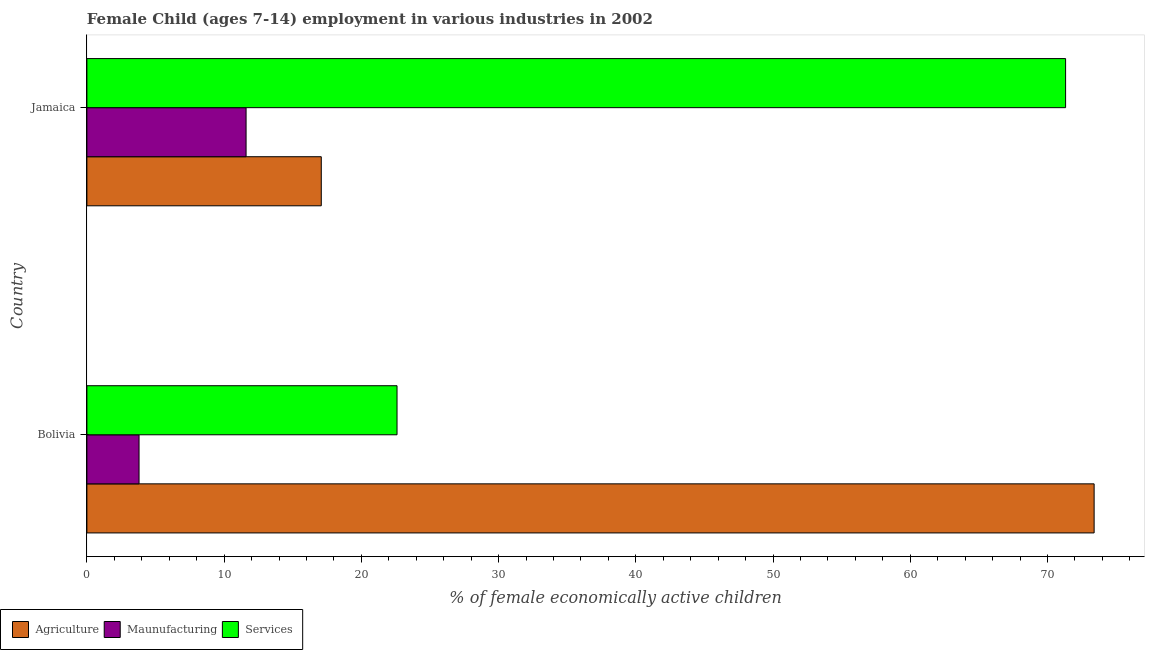How many different coloured bars are there?
Offer a terse response. 3. Across all countries, what is the maximum percentage of economically active children in agriculture?
Provide a short and direct response. 73.4. Across all countries, what is the minimum percentage of economically active children in agriculture?
Your response must be concise. 17.08. In which country was the percentage of economically active children in services maximum?
Your answer should be very brief. Jamaica. What is the total percentage of economically active children in manufacturing in the graph?
Give a very brief answer. 15.4. What is the difference between the percentage of economically active children in agriculture in Bolivia and that in Jamaica?
Provide a succinct answer. 56.32. What is the difference between the percentage of economically active children in manufacturing in Bolivia and the percentage of economically active children in services in Jamaica?
Your answer should be compact. -67.52. What is the average percentage of economically active children in agriculture per country?
Keep it short and to the point. 45.24. What is the difference between the percentage of economically active children in agriculture and percentage of economically active children in manufacturing in Bolivia?
Give a very brief answer. 69.6. In how many countries, is the percentage of economically active children in services greater than 74 %?
Provide a short and direct response. 0. What is the ratio of the percentage of economically active children in manufacturing in Bolivia to that in Jamaica?
Give a very brief answer. 0.33. Is the percentage of economically active children in manufacturing in Bolivia less than that in Jamaica?
Provide a succinct answer. Yes. What does the 1st bar from the top in Jamaica represents?
Make the answer very short. Services. What does the 3rd bar from the bottom in Bolivia represents?
Provide a short and direct response. Services. Are all the bars in the graph horizontal?
Your response must be concise. Yes. What is the difference between two consecutive major ticks on the X-axis?
Your answer should be very brief. 10. Are the values on the major ticks of X-axis written in scientific E-notation?
Provide a short and direct response. No. How many legend labels are there?
Keep it short and to the point. 3. What is the title of the graph?
Give a very brief answer. Female Child (ages 7-14) employment in various industries in 2002. What is the label or title of the X-axis?
Offer a terse response. % of female economically active children. What is the label or title of the Y-axis?
Your answer should be very brief. Country. What is the % of female economically active children in Agriculture in Bolivia?
Keep it short and to the point. 73.4. What is the % of female economically active children in Maunufacturing in Bolivia?
Offer a very short reply. 3.8. What is the % of female economically active children in Services in Bolivia?
Your response must be concise. 22.6. What is the % of female economically active children in Agriculture in Jamaica?
Your answer should be compact. 17.08. What is the % of female economically active children in Services in Jamaica?
Offer a terse response. 71.32. Across all countries, what is the maximum % of female economically active children in Agriculture?
Your answer should be compact. 73.4. Across all countries, what is the maximum % of female economically active children of Maunufacturing?
Offer a very short reply. 11.6. Across all countries, what is the maximum % of female economically active children in Services?
Offer a terse response. 71.32. Across all countries, what is the minimum % of female economically active children in Agriculture?
Offer a terse response. 17.08. Across all countries, what is the minimum % of female economically active children in Services?
Make the answer very short. 22.6. What is the total % of female economically active children in Agriculture in the graph?
Offer a very short reply. 90.48. What is the total % of female economically active children in Maunufacturing in the graph?
Keep it short and to the point. 15.4. What is the total % of female economically active children in Services in the graph?
Keep it short and to the point. 93.92. What is the difference between the % of female economically active children of Agriculture in Bolivia and that in Jamaica?
Provide a succinct answer. 56.32. What is the difference between the % of female economically active children in Services in Bolivia and that in Jamaica?
Your answer should be very brief. -48.72. What is the difference between the % of female economically active children of Agriculture in Bolivia and the % of female economically active children of Maunufacturing in Jamaica?
Provide a short and direct response. 61.8. What is the difference between the % of female economically active children in Agriculture in Bolivia and the % of female economically active children in Services in Jamaica?
Offer a very short reply. 2.08. What is the difference between the % of female economically active children in Maunufacturing in Bolivia and the % of female economically active children in Services in Jamaica?
Make the answer very short. -67.52. What is the average % of female economically active children of Agriculture per country?
Your answer should be compact. 45.24. What is the average % of female economically active children of Services per country?
Provide a short and direct response. 46.96. What is the difference between the % of female economically active children in Agriculture and % of female economically active children in Maunufacturing in Bolivia?
Ensure brevity in your answer.  69.6. What is the difference between the % of female economically active children in Agriculture and % of female economically active children in Services in Bolivia?
Your response must be concise. 50.8. What is the difference between the % of female economically active children of Maunufacturing and % of female economically active children of Services in Bolivia?
Your answer should be very brief. -18.8. What is the difference between the % of female economically active children in Agriculture and % of female economically active children in Maunufacturing in Jamaica?
Ensure brevity in your answer.  5.48. What is the difference between the % of female economically active children in Agriculture and % of female economically active children in Services in Jamaica?
Your response must be concise. -54.24. What is the difference between the % of female economically active children of Maunufacturing and % of female economically active children of Services in Jamaica?
Give a very brief answer. -59.72. What is the ratio of the % of female economically active children in Agriculture in Bolivia to that in Jamaica?
Offer a very short reply. 4.3. What is the ratio of the % of female economically active children of Maunufacturing in Bolivia to that in Jamaica?
Make the answer very short. 0.33. What is the ratio of the % of female economically active children in Services in Bolivia to that in Jamaica?
Provide a succinct answer. 0.32. What is the difference between the highest and the second highest % of female economically active children of Agriculture?
Give a very brief answer. 56.32. What is the difference between the highest and the second highest % of female economically active children of Services?
Make the answer very short. 48.72. What is the difference between the highest and the lowest % of female economically active children in Agriculture?
Provide a succinct answer. 56.32. What is the difference between the highest and the lowest % of female economically active children of Maunufacturing?
Provide a succinct answer. 7.8. What is the difference between the highest and the lowest % of female economically active children in Services?
Offer a very short reply. 48.72. 